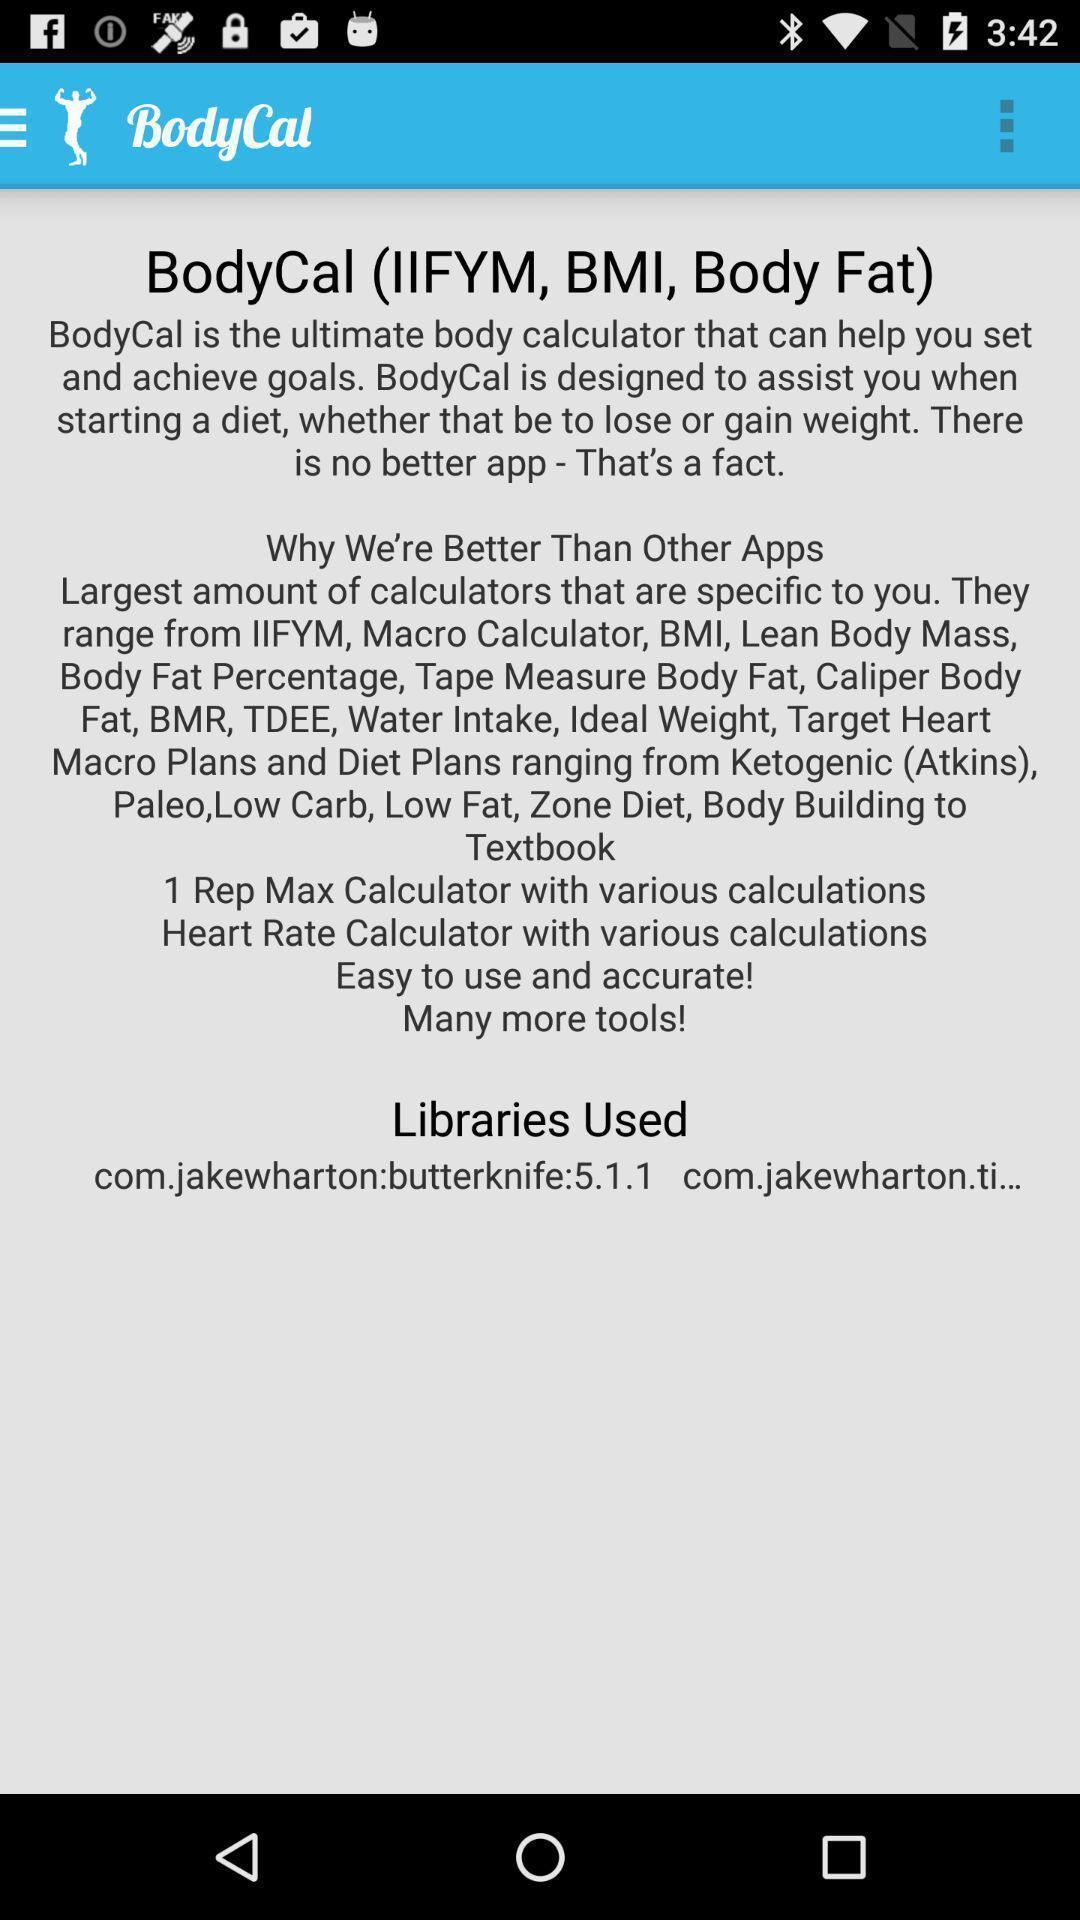Give me a summary of this screen capture. Page displaying the information about a social application. 